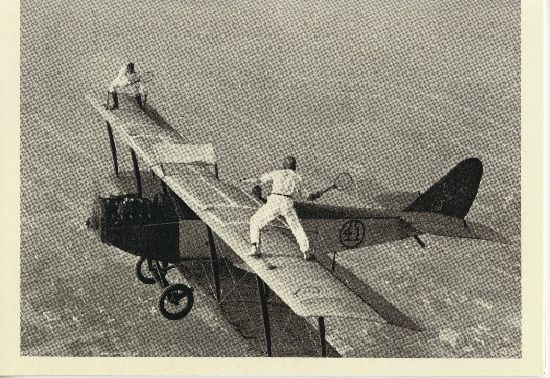Describe the objects in this image and their specific colors. I can see airplane in beige, black, gray, darkgray, and lightgray tones, people in beige, darkgray, lightgray, and gray tones, people in beige, gray, darkgray, and black tones, tennis racket in beige, gray, darkgray, and black tones, and tennis racket in beige, darkgray, gray, and lightgray tones in this image. 